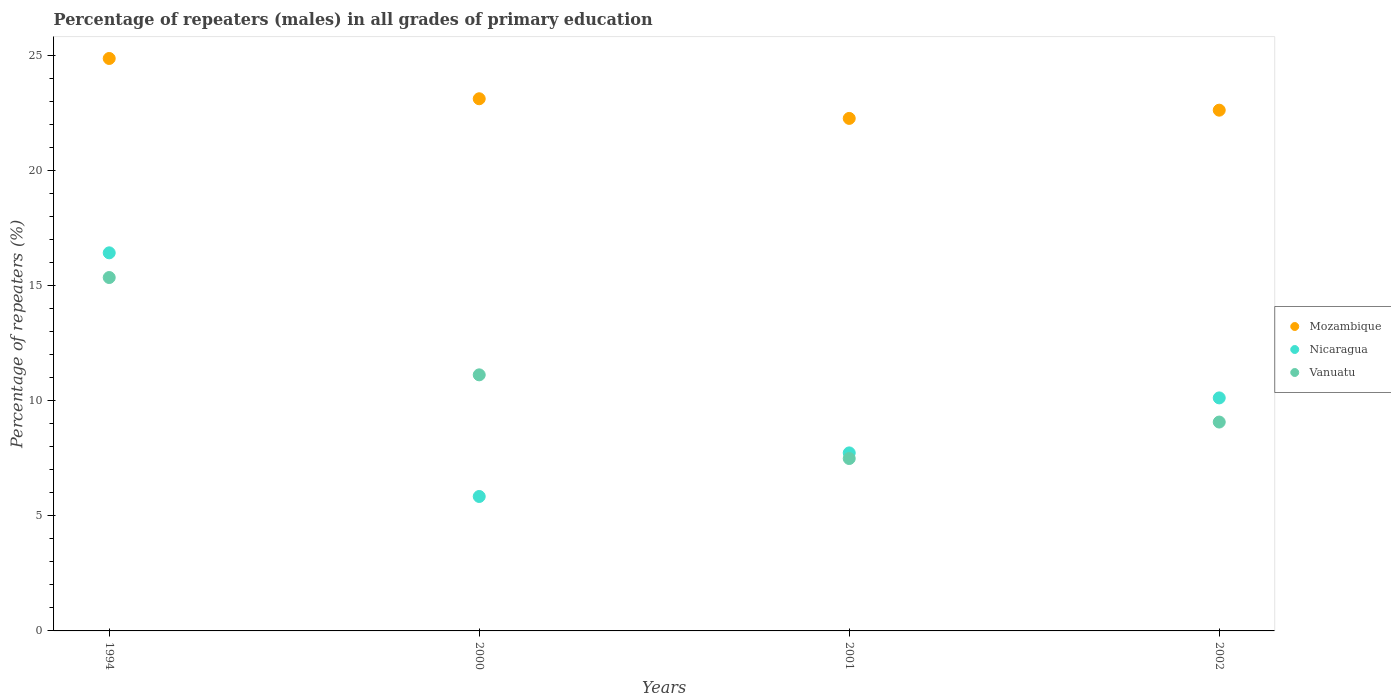How many different coloured dotlines are there?
Make the answer very short. 3. Is the number of dotlines equal to the number of legend labels?
Provide a short and direct response. Yes. What is the percentage of repeaters (males) in Mozambique in 2002?
Give a very brief answer. 22.63. Across all years, what is the maximum percentage of repeaters (males) in Mozambique?
Give a very brief answer. 24.88. Across all years, what is the minimum percentage of repeaters (males) in Mozambique?
Provide a succinct answer. 22.27. In which year was the percentage of repeaters (males) in Mozambique maximum?
Give a very brief answer. 1994. In which year was the percentage of repeaters (males) in Vanuatu minimum?
Provide a succinct answer. 2001. What is the total percentage of repeaters (males) in Nicaragua in the graph?
Offer a terse response. 40.14. What is the difference between the percentage of repeaters (males) in Vanuatu in 1994 and that in 2000?
Give a very brief answer. 4.23. What is the difference between the percentage of repeaters (males) in Nicaragua in 2002 and the percentage of repeaters (males) in Mozambique in 2000?
Ensure brevity in your answer.  -13. What is the average percentage of repeaters (males) in Nicaragua per year?
Ensure brevity in your answer.  10.03. In the year 2001, what is the difference between the percentage of repeaters (males) in Vanuatu and percentage of repeaters (males) in Mozambique?
Your answer should be very brief. -14.78. What is the ratio of the percentage of repeaters (males) in Vanuatu in 2000 to that in 2001?
Your answer should be very brief. 1.49. What is the difference between the highest and the second highest percentage of repeaters (males) in Mozambique?
Offer a very short reply. 1.75. What is the difference between the highest and the lowest percentage of repeaters (males) in Mozambique?
Provide a succinct answer. 2.6. Is the sum of the percentage of repeaters (males) in Nicaragua in 1994 and 2000 greater than the maximum percentage of repeaters (males) in Mozambique across all years?
Your answer should be compact. No. Is it the case that in every year, the sum of the percentage of repeaters (males) in Mozambique and percentage of repeaters (males) in Vanuatu  is greater than the percentage of repeaters (males) in Nicaragua?
Provide a succinct answer. Yes. Does the percentage of repeaters (males) in Vanuatu monotonically increase over the years?
Offer a terse response. No. Is the percentage of repeaters (males) in Mozambique strictly less than the percentage of repeaters (males) in Nicaragua over the years?
Give a very brief answer. No. How many dotlines are there?
Offer a terse response. 3. How many years are there in the graph?
Your answer should be very brief. 4. What is the difference between two consecutive major ticks on the Y-axis?
Provide a short and direct response. 5. Does the graph contain any zero values?
Your response must be concise. No. Does the graph contain grids?
Give a very brief answer. No. How many legend labels are there?
Give a very brief answer. 3. How are the legend labels stacked?
Your response must be concise. Vertical. What is the title of the graph?
Keep it short and to the point. Percentage of repeaters (males) in all grades of primary education. Does "Austria" appear as one of the legend labels in the graph?
Your answer should be compact. No. What is the label or title of the Y-axis?
Make the answer very short. Percentage of repeaters (%). What is the Percentage of repeaters (%) in Mozambique in 1994?
Keep it short and to the point. 24.88. What is the Percentage of repeaters (%) of Nicaragua in 1994?
Your response must be concise. 16.43. What is the Percentage of repeaters (%) of Vanuatu in 1994?
Give a very brief answer. 15.36. What is the Percentage of repeaters (%) in Mozambique in 2000?
Keep it short and to the point. 23.13. What is the Percentage of repeaters (%) in Nicaragua in 2000?
Your answer should be compact. 5.84. What is the Percentage of repeaters (%) of Vanuatu in 2000?
Provide a short and direct response. 11.13. What is the Percentage of repeaters (%) of Mozambique in 2001?
Your response must be concise. 22.27. What is the Percentage of repeaters (%) in Nicaragua in 2001?
Make the answer very short. 7.74. What is the Percentage of repeaters (%) of Vanuatu in 2001?
Give a very brief answer. 7.49. What is the Percentage of repeaters (%) in Mozambique in 2002?
Your response must be concise. 22.63. What is the Percentage of repeaters (%) in Nicaragua in 2002?
Your answer should be compact. 10.13. What is the Percentage of repeaters (%) in Vanuatu in 2002?
Your response must be concise. 9.08. Across all years, what is the maximum Percentage of repeaters (%) in Mozambique?
Offer a terse response. 24.88. Across all years, what is the maximum Percentage of repeaters (%) in Nicaragua?
Ensure brevity in your answer.  16.43. Across all years, what is the maximum Percentage of repeaters (%) in Vanuatu?
Offer a very short reply. 15.36. Across all years, what is the minimum Percentage of repeaters (%) in Mozambique?
Make the answer very short. 22.27. Across all years, what is the minimum Percentage of repeaters (%) of Nicaragua?
Offer a terse response. 5.84. Across all years, what is the minimum Percentage of repeaters (%) in Vanuatu?
Provide a succinct answer. 7.49. What is the total Percentage of repeaters (%) in Mozambique in the graph?
Your response must be concise. 92.91. What is the total Percentage of repeaters (%) in Nicaragua in the graph?
Ensure brevity in your answer.  40.14. What is the total Percentage of repeaters (%) of Vanuatu in the graph?
Your response must be concise. 43.06. What is the difference between the Percentage of repeaters (%) in Mozambique in 1994 and that in 2000?
Provide a short and direct response. 1.75. What is the difference between the Percentage of repeaters (%) of Nicaragua in 1994 and that in 2000?
Provide a short and direct response. 10.59. What is the difference between the Percentage of repeaters (%) in Vanuatu in 1994 and that in 2000?
Provide a short and direct response. 4.23. What is the difference between the Percentage of repeaters (%) in Mozambique in 1994 and that in 2001?
Offer a terse response. 2.6. What is the difference between the Percentage of repeaters (%) of Nicaragua in 1994 and that in 2001?
Provide a short and direct response. 8.69. What is the difference between the Percentage of repeaters (%) in Vanuatu in 1994 and that in 2001?
Your answer should be very brief. 7.87. What is the difference between the Percentage of repeaters (%) in Mozambique in 1994 and that in 2002?
Keep it short and to the point. 2.25. What is the difference between the Percentage of repeaters (%) of Nicaragua in 1994 and that in 2002?
Your answer should be compact. 6.3. What is the difference between the Percentage of repeaters (%) of Vanuatu in 1994 and that in 2002?
Your response must be concise. 6.28. What is the difference between the Percentage of repeaters (%) of Mozambique in 2000 and that in 2001?
Give a very brief answer. 0.85. What is the difference between the Percentage of repeaters (%) of Nicaragua in 2000 and that in 2001?
Your response must be concise. -1.89. What is the difference between the Percentage of repeaters (%) in Vanuatu in 2000 and that in 2001?
Ensure brevity in your answer.  3.64. What is the difference between the Percentage of repeaters (%) of Mozambique in 2000 and that in 2002?
Provide a succinct answer. 0.5. What is the difference between the Percentage of repeaters (%) of Nicaragua in 2000 and that in 2002?
Give a very brief answer. -4.28. What is the difference between the Percentage of repeaters (%) in Vanuatu in 2000 and that in 2002?
Offer a very short reply. 2.05. What is the difference between the Percentage of repeaters (%) in Mozambique in 2001 and that in 2002?
Offer a terse response. -0.36. What is the difference between the Percentage of repeaters (%) in Nicaragua in 2001 and that in 2002?
Make the answer very short. -2.39. What is the difference between the Percentage of repeaters (%) of Vanuatu in 2001 and that in 2002?
Give a very brief answer. -1.59. What is the difference between the Percentage of repeaters (%) in Mozambique in 1994 and the Percentage of repeaters (%) in Nicaragua in 2000?
Your response must be concise. 19.04. What is the difference between the Percentage of repeaters (%) in Mozambique in 1994 and the Percentage of repeaters (%) in Vanuatu in 2000?
Provide a succinct answer. 13.75. What is the difference between the Percentage of repeaters (%) in Nicaragua in 1994 and the Percentage of repeaters (%) in Vanuatu in 2000?
Make the answer very short. 5.3. What is the difference between the Percentage of repeaters (%) in Mozambique in 1994 and the Percentage of repeaters (%) in Nicaragua in 2001?
Provide a succinct answer. 17.14. What is the difference between the Percentage of repeaters (%) of Mozambique in 1994 and the Percentage of repeaters (%) of Vanuatu in 2001?
Keep it short and to the point. 17.39. What is the difference between the Percentage of repeaters (%) of Nicaragua in 1994 and the Percentage of repeaters (%) of Vanuatu in 2001?
Offer a very short reply. 8.94. What is the difference between the Percentage of repeaters (%) of Mozambique in 1994 and the Percentage of repeaters (%) of Nicaragua in 2002?
Your response must be concise. 14.75. What is the difference between the Percentage of repeaters (%) in Mozambique in 1994 and the Percentage of repeaters (%) in Vanuatu in 2002?
Your response must be concise. 15.8. What is the difference between the Percentage of repeaters (%) in Nicaragua in 1994 and the Percentage of repeaters (%) in Vanuatu in 2002?
Offer a very short reply. 7.35. What is the difference between the Percentage of repeaters (%) in Mozambique in 2000 and the Percentage of repeaters (%) in Nicaragua in 2001?
Make the answer very short. 15.39. What is the difference between the Percentage of repeaters (%) of Mozambique in 2000 and the Percentage of repeaters (%) of Vanuatu in 2001?
Keep it short and to the point. 15.64. What is the difference between the Percentage of repeaters (%) in Nicaragua in 2000 and the Percentage of repeaters (%) in Vanuatu in 2001?
Make the answer very short. -1.65. What is the difference between the Percentage of repeaters (%) of Mozambique in 2000 and the Percentage of repeaters (%) of Nicaragua in 2002?
Make the answer very short. 13. What is the difference between the Percentage of repeaters (%) of Mozambique in 2000 and the Percentage of repeaters (%) of Vanuatu in 2002?
Keep it short and to the point. 14.05. What is the difference between the Percentage of repeaters (%) of Nicaragua in 2000 and the Percentage of repeaters (%) of Vanuatu in 2002?
Your answer should be very brief. -3.23. What is the difference between the Percentage of repeaters (%) of Mozambique in 2001 and the Percentage of repeaters (%) of Nicaragua in 2002?
Keep it short and to the point. 12.15. What is the difference between the Percentage of repeaters (%) of Mozambique in 2001 and the Percentage of repeaters (%) of Vanuatu in 2002?
Offer a very short reply. 13.2. What is the difference between the Percentage of repeaters (%) of Nicaragua in 2001 and the Percentage of repeaters (%) of Vanuatu in 2002?
Keep it short and to the point. -1.34. What is the average Percentage of repeaters (%) in Mozambique per year?
Provide a succinct answer. 23.23. What is the average Percentage of repeaters (%) of Nicaragua per year?
Make the answer very short. 10.03. What is the average Percentage of repeaters (%) of Vanuatu per year?
Your response must be concise. 10.76. In the year 1994, what is the difference between the Percentage of repeaters (%) in Mozambique and Percentage of repeaters (%) in Nicaragua?
Keep it short and to the point. 8.45. In the year 1994, what is the difference between the Percentage of repeaters (%) of Mozambique and Percentage of repeaters (%) of Vanuatu?
Keep it short and to the point. 9.52. In the year 1994, what is the difference between the Percentage of repeaters (%) in Nicaragua and Percentage of repeaters (%) in Vanuatu?
Offer a terse response. 1.07. In the year 2000, what is the difference between the Percentage of repeaters (%) of Mozambique and Percentage of repeaters (%) of Nicaragua?
Provide a short and direct response. 17.28. In the year 2000, what is the difference between the Percentage of repeaters (%) in Mozambique and Percentage of repeaters (%) in Vanuatu?
Your response must be concise. 12. In the year 2000, what is the difference between the Percentage of repeaters (%) in Nicaragua and Percentage of repeaters (%) in Vanuatu?
Make the answer very short. -5.29. In the year 2001, what is the difference between the Percentage of repeaters (%) in Mozambique and Percentage of repeaters (%) in Nicaragua?
Ensure brevity in your answer.  14.54. In the year 2001, what is the difference between the Percentage of repeaters (%) in Mozambique and Percentage of repeaters (%) in Vanuatu?
Provide a succinct answer. 14.78. In the year 2001, what is the difference between the Percentage of repeaters (%) in Nicaragua and Percentage of repeaters (%) in Vanuatu?
Provide a short and direct response. 0.24. In the year 2002, what is the difference between the Percentage of repeaters (%) of Mozambique and Percentage of repeaters (%) of Nicaragua?
Your response must be concise. 12.5. In the year 2002, what is the difference between the Percentage of repeaters (%) of Mozambique and Percentage of repeaters (%) of Vanuatu?
Ensure brevity in your answer.  13.55. In the year 2002, what is the difference between the Percentage of repeaters (%) of Nicaragua and Percentage of repeaters (%) of Vanuatu?
Make the answer very short. 1.05. What is the ratio of the Percentage of repeaters (%) of Mozambique in 1994 to that in 2000?
Give a very brief answer. 1.08. What is the ratio of the Percentage of repeaters (%) in Nicaragua in 1994 to that in 2000?
Provide a succinct answer. 2.81. What is the ratio of the Percentage of repeaters (%) of Vanuatu in 1994 to that in 2000?
Make the answer very short. 1.38. What is the ratio of the Percentage of repeaters (%) of Mozambique in 1994 to that in 2001?
Your response must be concise. 1.12. What is the ratio of the Percentage of repeaters (%) in Nicaragua in 1994 to that in 2001?
Offer a very short reply. 2.12. What is the ratio of the Percentage of repeaters (%) of Vanuatu in 1994 to that in 2001?
Your answer should be compact. 2.05. What is the ratio of the Percentage of repeaters (%) of Mozambique in 1994 to that in 2002?
Make the answer very short. 1.1. What is the ratio of the Percentage of repeaters (%) of Nicaragua in 1994 to that in 2002?
Provide a succinct answer. 1.62. What is the ratio of the Percentage of repeaters (%) of Vanuatu in 1994 to that in 2002?
Offer a terse response. 1.69. What is the ratio of the Percentage of repeaters (%) in Mozambique in 2000 to that in 2001?
Provide a succinct answer. 1.04. What is the ratio of the Percentage of repeaters (%) of Nicaragua in 2000 to that in 2001?
Your answer should be very brief. 0.76. What is the ratio of the Percentage of repeaters (%) of Vanuatu in 2000 to that in 2001?
Make the answer very short. 1.49. What is the ratio of the Percentage of repeaters (%) of Mozambique in 2000 to that in 2002?
Your answer should be compact. 1.02. What is the ratio of the Percentage of repeaters (%) in Nicaragua in 2000 to that in 2002?
Provide a succinct answer. 0.58. What is the ratio of the Percentage of repeaters (%) of Vanuatu in 2000 to that in 2002?
Offer a very short reply. 1.23. What is the ratio of the Percentage of repeaters (%) of Mozambique in 2001 to that in 2002?
Keep it short and to the point. 0.98. What is the ratio of the Percentage of repeaters (%) of Nicaragua in 2001 to that in 2002?
Your answer should be very brief. 0.76. What is the ratio of the Percentage of repeaters (%) of Vanuatu in 2001 to that in 2002?
Your answer should be compact. 0.83. What is the difference between the highest and the second highest Percentage of repeaters (%) in Mozambique?
Your response must be concise. 1.75. What is the difference between the highest and the second highest Percentage of repeaters (%) of Nicaragua?
Your answer should be compact. 6.3. What is the difference between the highest and the second highest Percentage of repeaters (%) of Vanuatu?
Your answer should be very brief. 4.23. What is the difference between the highest and the lowest Percentage of repeaters (%) in Mozambique?
Offer a very short reply. 2.6. What is the difference between the highest and the lowest Percentage of repeaters (%) in Nicaragua?
Your answer should be compact. 10.59. What is the difference between the highest and the lowest Percentage of repeaters (%) of Vanuatu?
Provide a short and direct response. 7.87. 